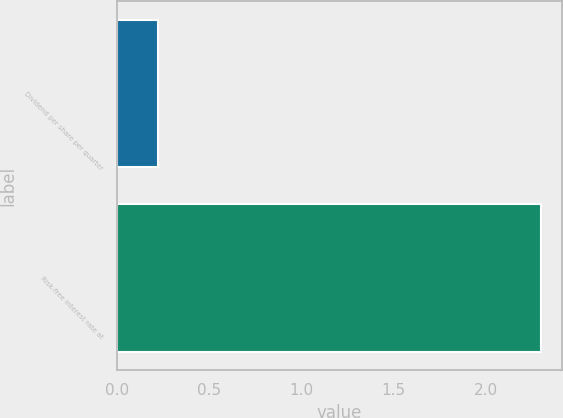Convert chart to OTSL. <chart><loc_0><loc_0><loc_500><loc_500><bar_chart><fcel>Dividend per share per quarter<fcel>Risk-free interest rate at<nl><fcel>0.22<fcel>2.3<nl></chart> 